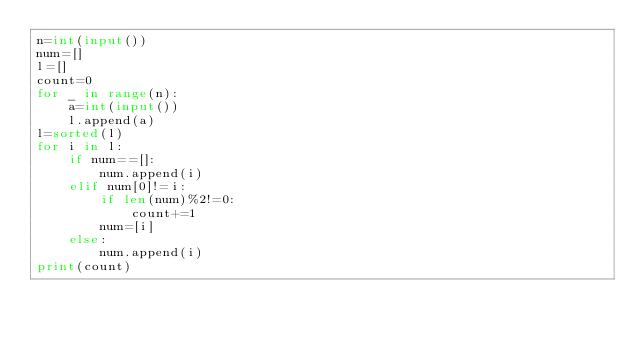<code> <loc_0><loc_0><loc_500><loc_500><_Python_>n=int(input())
num=[]
l=[]
count=0
for _ in range(n):
    a=int(input())
    l.append(a)
l=sorted(l)
for i in l:
    if num==[]:
        num.append(i)
    elif num[0]!=i:
        if len(num)%2!=0:
            count+=1
        num=[i]
    else:
        num.append(i)
print(count)</code> 